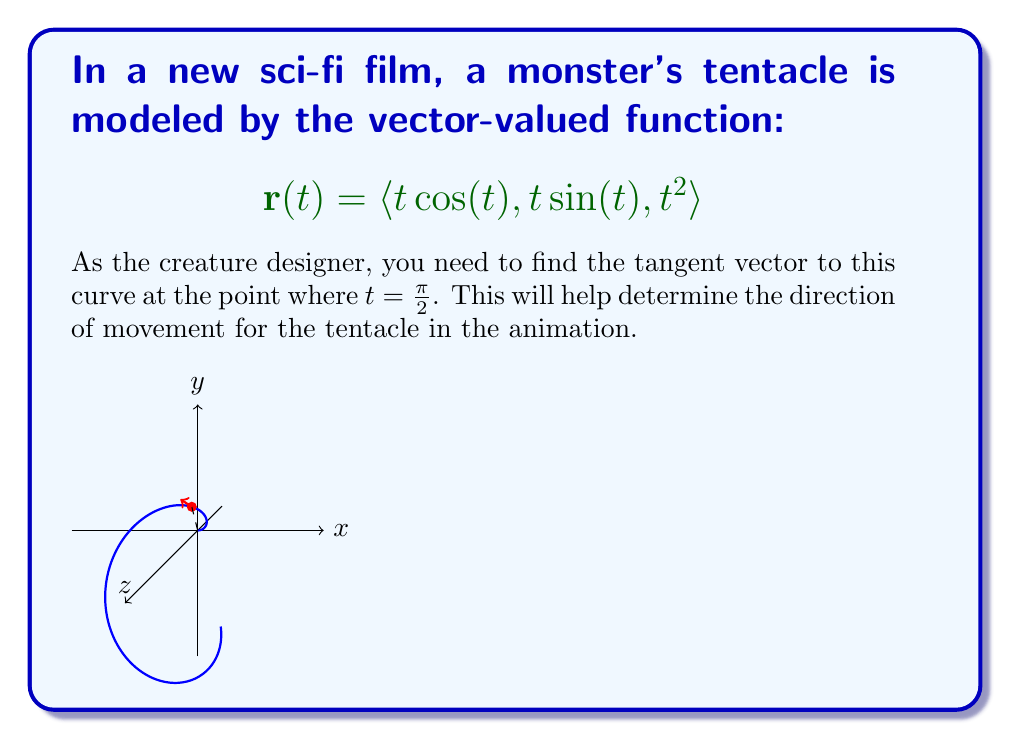Show me your answer to this math problem. To find the tangent vector, we need to calculate the derivative of the vector-valued function $\mathbf{r}(t)$ and then evaluate it at $t = \frac{\pi}{2}$. Let's break this down step-by-step:

1) First, let's find $\mathbf{r}'(t)$:
   $$\mathbf{r}'(t) = \langle \frac{d}{dt}(t\cos(t)), \frac{d}{dt}(t\sin(t)), \frac{d}{dt}(t^2) \rangle$$

2) Using the product rule and derivative rules:
   $$\mathbf{r}'(t) = \langle \cos(t) - t\sin(t), \sin(t) + t\cos(t), 2t \rangle$$

3) Now, we need to evaluate this at $t = \frac{\pi}{2}$:
   $$\mathbf{r}'(\frac{\pi}{2}) = \langle \cos(\frac{\pi}{2}) - \frac{\pi}{2}\sin(\frac{\pi}{2}), \sin(\frac{\pi}{2}) + \frac{\pi}{2}\cos(\frac{\pi}{2}), 2(\frac{\pi}{2}) \rangle$$

4) Simplify, knowing that $\cos(\frac{\pi}{2}) = 0$ and $\sin(\frac{\pi}{2}) = 1$:
   $$\mathbf{r}'(\frac{\pi}{2}) = \langle 0 - \frac{\pi}{2}, 1 + 0, \pi \rangle = \langle -\frac{\pi}{2}, 1, \pi \rangle$$

5) This vector represents the tangent vector to the curve at $t = \frac{\pi}{2}$.
Answer: $\langle -\frac{\pi}{2}, 1, \pi \rangle$ 